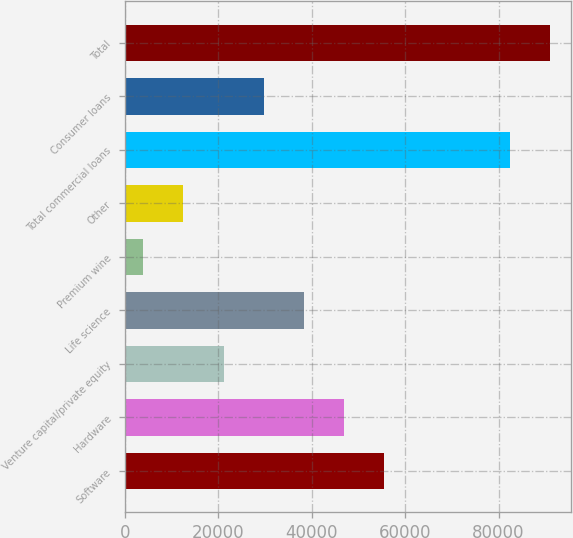Convert chart. <chart><loc_0><loc_0><loc_500><loc_500><bar_chart><fcel>Software<fcel>Hardware<fcel>Venture capital/private equity<fcel>Life science<fcel>Premium wine<fcel>Other<fcel>Total commercial loans<fcel>Consumer loans<fcel>Total<nl><fcel>55533.8<fcel>46930.5<fcel>21120.6<fcel>38327.2<fcel>3914<fcel>12517.3<fcel>82366<fcel>29723.9<fcel>90969.3<nl></chart> 